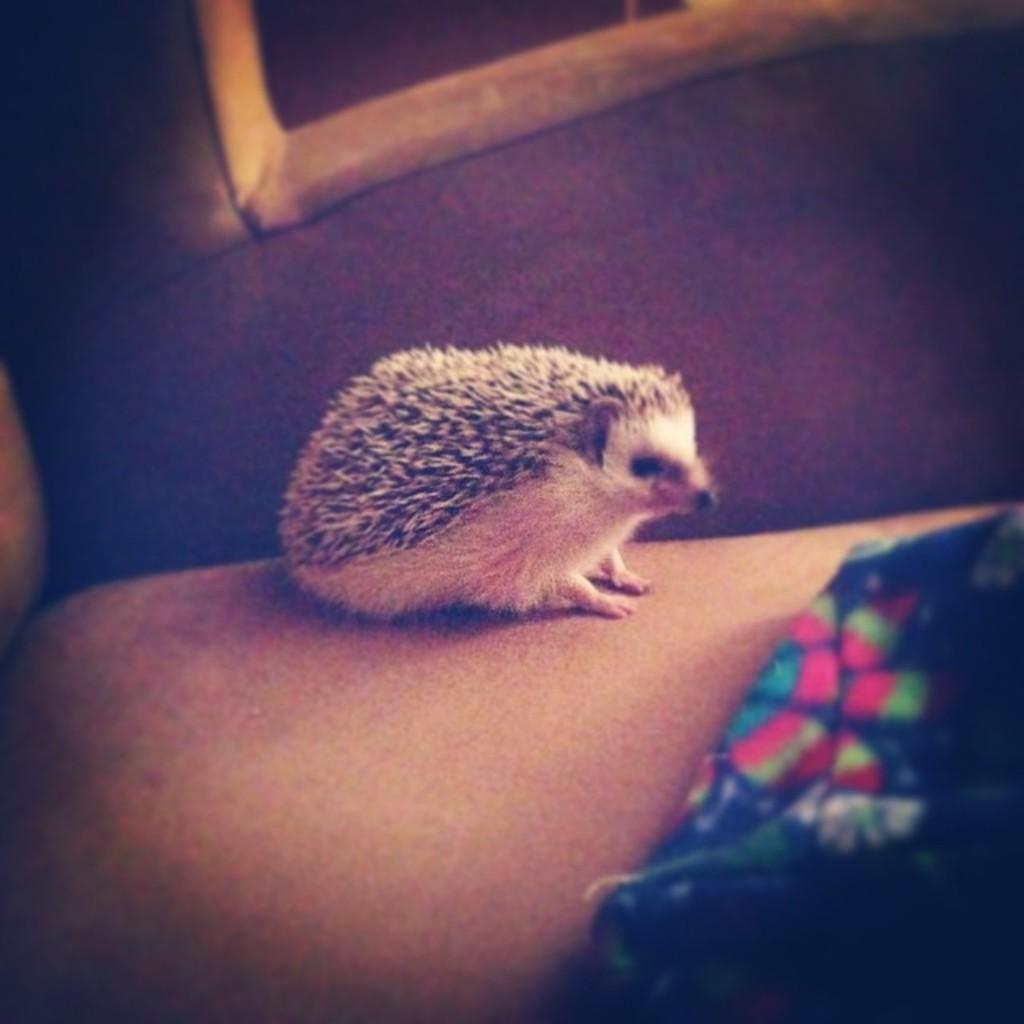Can you describe this image briefly? In this image we can see an animal on the surface. 